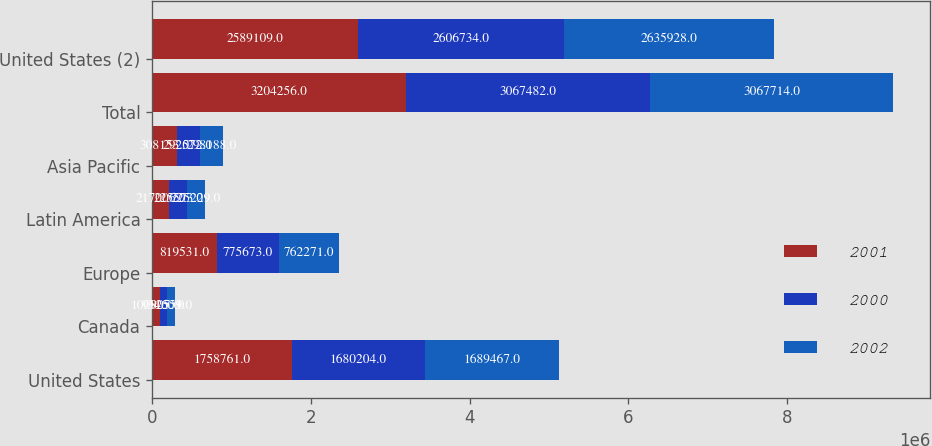Convert chart. <chart><loc_0><loc_0><loc_500><loc_500><stacked_bar_chart><ecel><fcel>United States<fcel>Canada<fcel>Europe<fcel>Latin America<fcel>Asia Pacific<fcel>Total<fcel>United States (2)<nl><fcel>2001<fcel>1.75876e+06<fcel>100805<fcel>819531<fcel>217006<fcel>308153<fcel>3.20426e+06<fcel>2.58911e+06<nl><fcel>2000<fcel>1.6802e+06<fcel>93460<fcel>775673<fcel>225573<fcel>292572<fcel>3.06748e+06<fcel>2.60673e+06<nl><fcel>2002<fcel>1.68947e+06<fcel>92559<fcel>762271<fcel>225229<fcel>298188<fcel>3.06771e+06<fcel>2.63593e+06<nl></chart> 